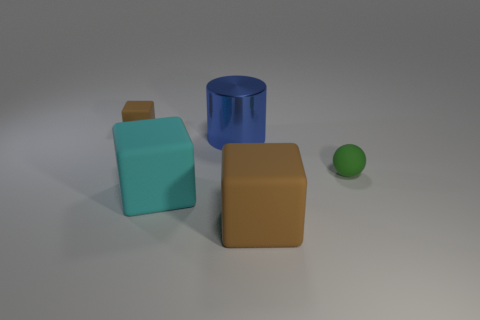The large brown thing that is made of the same material as the sphere is what shape?
Keep it short and to the point. Cube. Is there anything else that is the same color as the shiny cylinder?
Provide a succinct answer. No. There is a rubber object that is the same color as the small cube; what is its size?
Keep it short and to the point. Large. Is the number of tiny brown cubes in front of the rubber sphere greater than the number of big objects?
Give a very brief answer. No. Do the tiny brown matte object and the brown rubber object in front of the small rubber cube have the same shape?
Provide a succinct answer. Yes. How many red rubber balls have the same size as the cyan cube?
Your answer should be compact. 0. What number of green matte objects are left of the big cylinder that is in front of the brown rubber object that is on the left side of the big metal cylinder?
Your response must be concise. 0. Are there an equal number of things that are in front of the small green matte sphere and big cyan objects right of the metallic cylinder?
Provide a succinct answer. No. How many big cyan things are the same shape as the green matte object?
Provide a short and direct response. 0. Is there a big cyan object that has the same material as the green sphere?
Offer a terse response. Yes. 